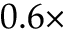<formula> <loc_0><loc_0><loc_500><loc_500>0 . 6 \times</formula> 